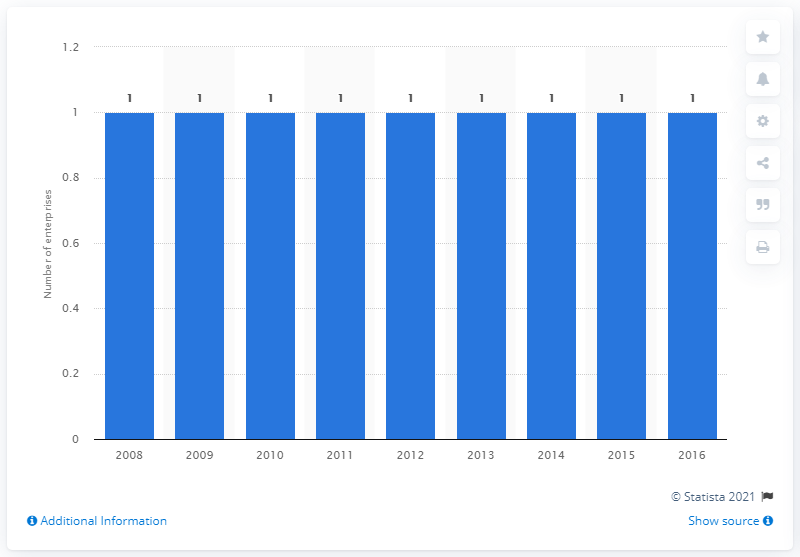Mention a couple of crucial points in this snapshot. In 2015, Luxembourg had one enterprise in the manufacture of cocoa, chocolate and sugar confectionery industry. 